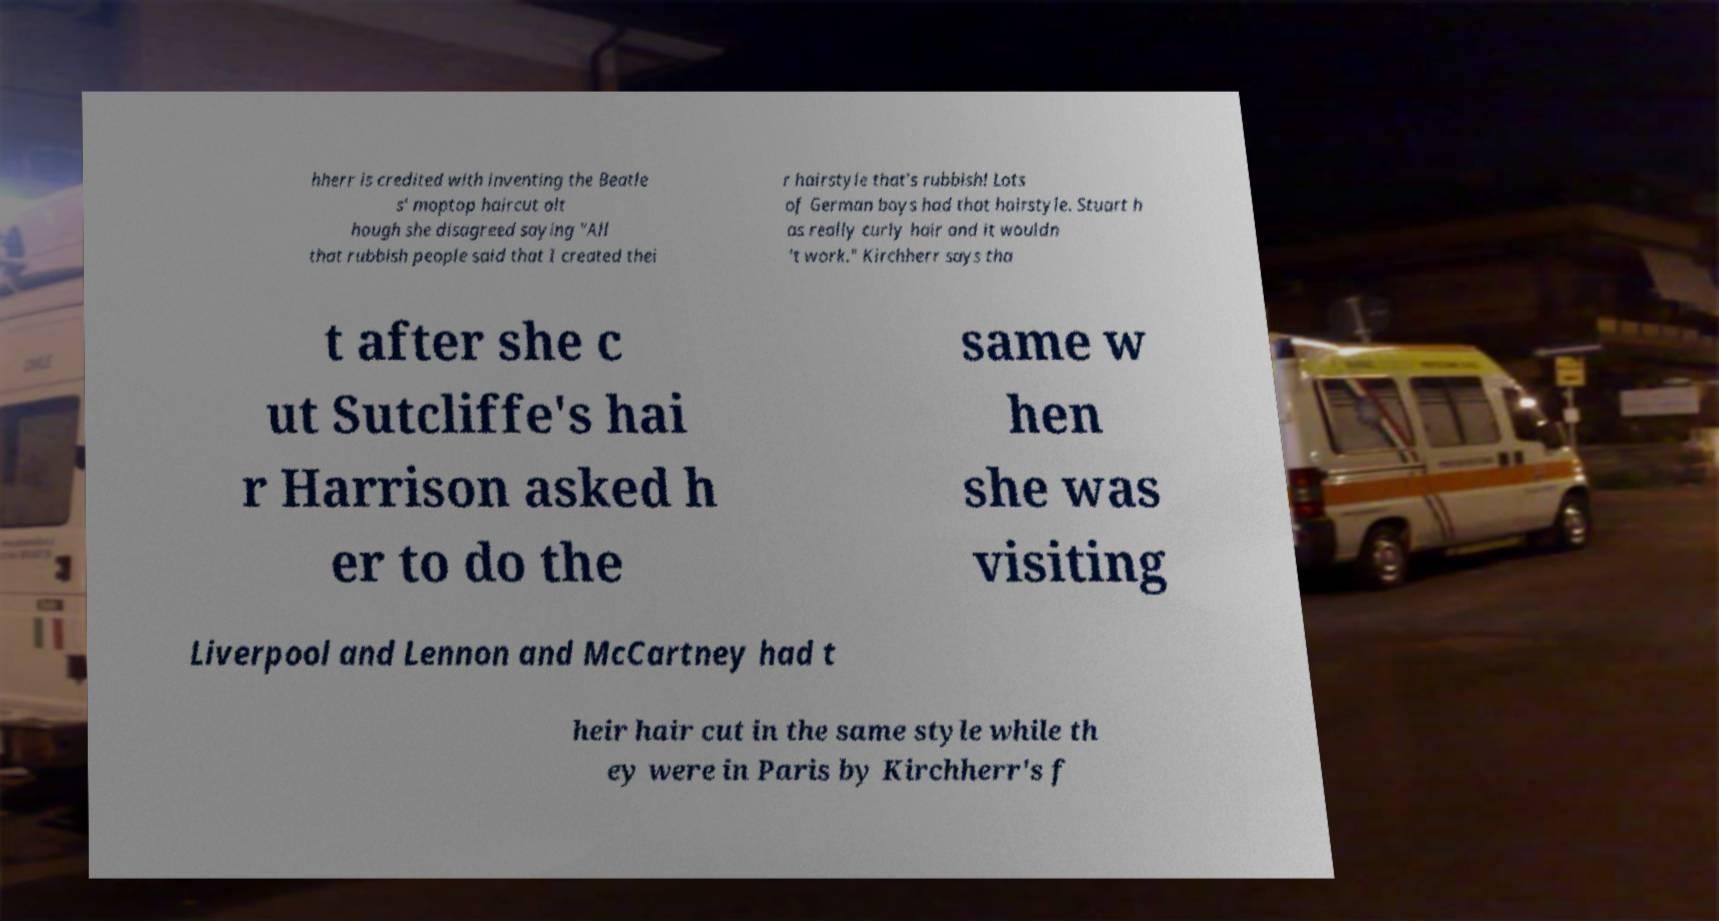Can you accurately transcribe the text from the provided image for me? hherr is credited with inventing the Beatle s' moptop haircut alt hough she disagreed saying "All that rubbish people said that I created thei r hairstyle that's rubbish! Lots of German boys had that hairstyle. Stuart h as really curly hair and it wouldn 't work." Kirchherr says tha t after she c ut Sutcliffe's hai r Harrison asked h er to do the same w hen she was visiting Liverpool and Lennon and McCartney had t heir hair cut in the same style while th ey were in Paris by Kirchherr's f 